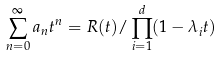<formula> <loc_0><loc_0><loc_500><loc_500>\sum _ { n = 0 } ^ { \infty } a _ { n } t ^ { n } = R ( t ) / \prod _ { i = 1 } ^ { d } ( 1 - \lambda _ { i } t )</formula> 